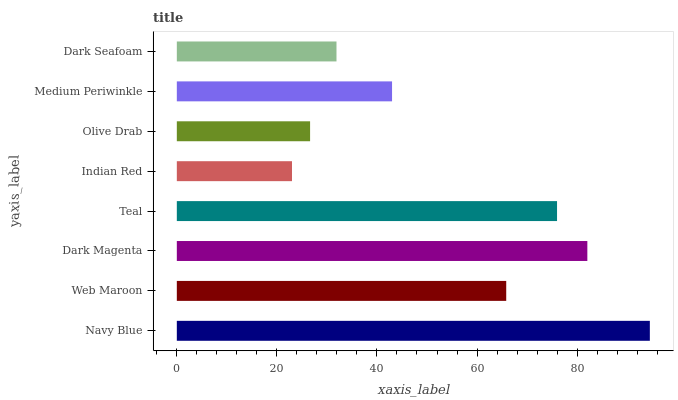Is Indian Red the minimum?
Answer yes or no. Yes. Is Navy Blue the maximum?
Answer yes or no. Yes. Is Web Maroon the minimum?
Answer yes or no. No. Is Web Maroon the maximum?
Answer yes or no. No. Is Navy Blue greater than Web Maroon?
Answer yes or no. Yes. Is Web Maroon less than Navy Blue?
Answer yes or no. Yes. Is Web Maroon greater than Navy Blue?
Answer yes or no. No. Is Navy Blue less than Web Maroon?
Answer yes or no. No. Is Web Maroon the high median?
Answer yes or no. Yes. Is Medium Periwinkle the low median?
Answer yes or no. Yes. Is Dark Seafoam the high median?
Answer yes or no. No. Is Navy Blue the low median?
Answer yes or no. No. 